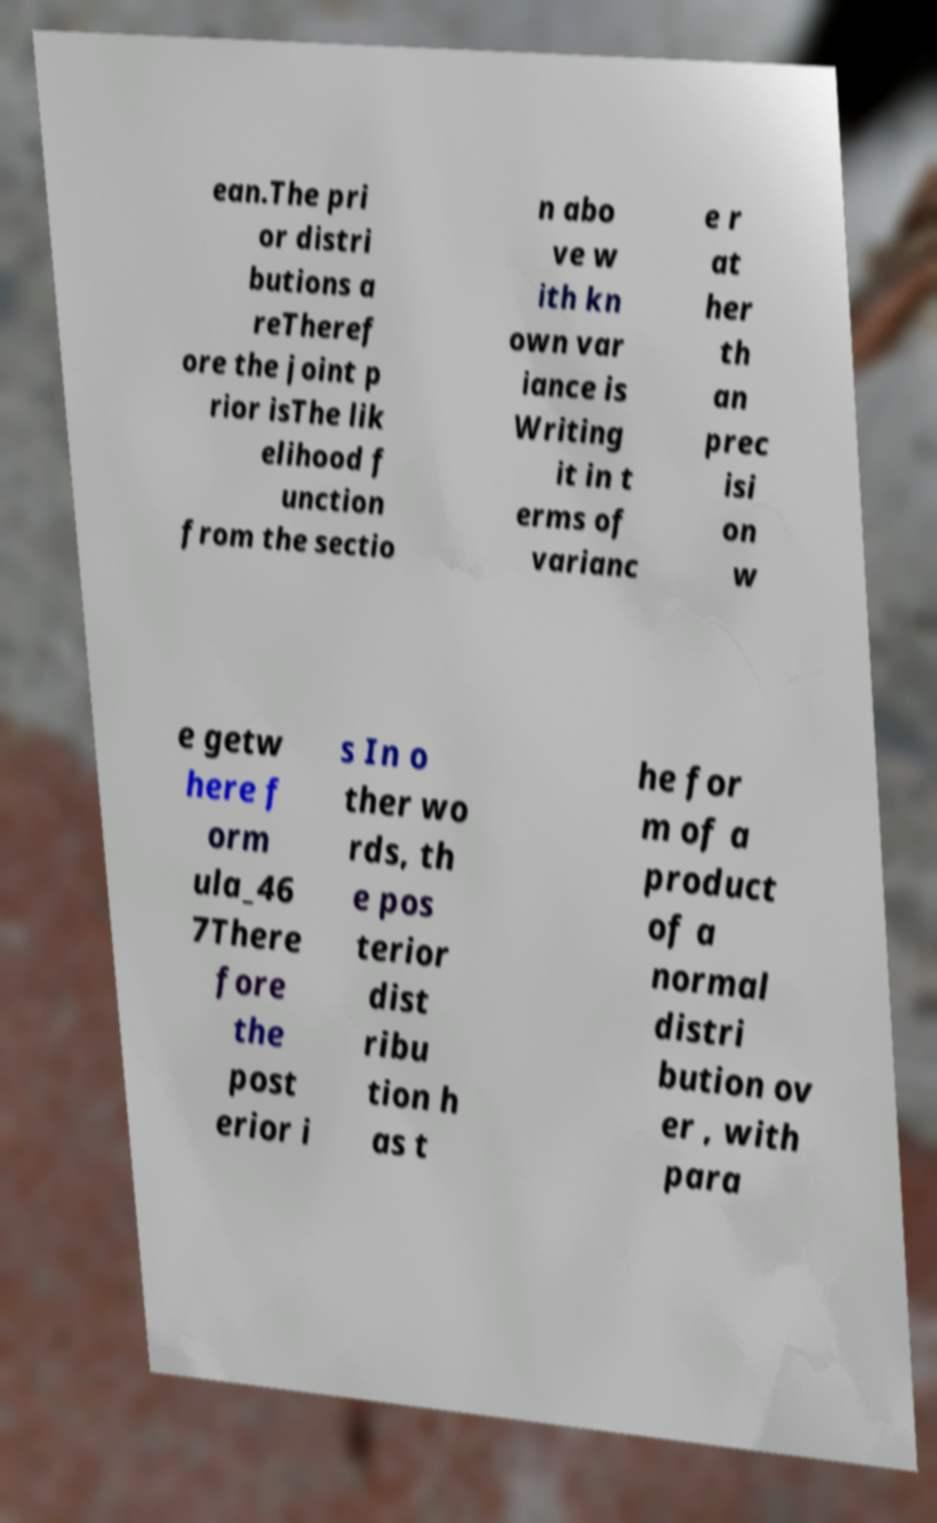Can you read and provide the text displayed in the image?This photo seems to have some interesting text. Can you extract and type it out for me? ean.The pri or distri butions a reTheref ore the joint p rior isThe lik elihood f unction from the sectio n abo ve w ith kn own var iance is Writing it in t erms of varianc e r at her th an prec isi on w e getw here f orm ula_46 7There fore the post erior i s In o ther wo rds, th e pos terior dist ribu tion h as t he for m of a product of a normal distri bution ov er , with para 